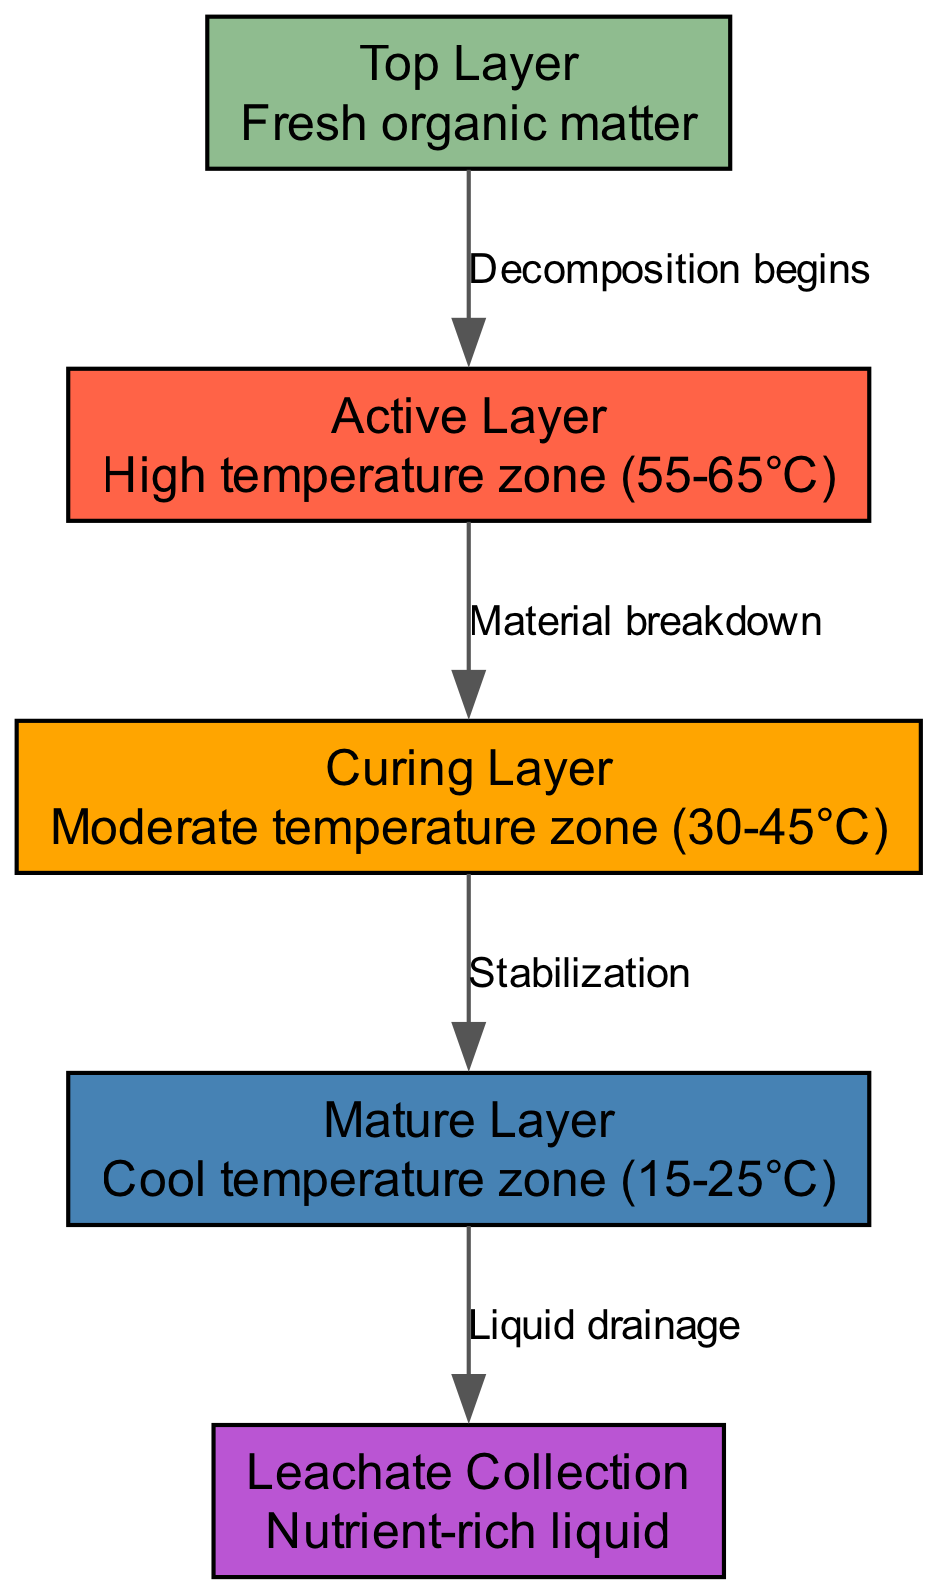What is the top layer of the compost bin? The diagram labels the top layer as "Fresh organic matter," indicating the type of material present in that section of the compost bin.
Answer: Fresh organic matter What temperature range is associated with the active layer? The diagram specifies that the active layer has a high temperature zone ranging from 55 to 65 degrees Celsius.
Answer: 55-65°C How many layers are there in total? By counting the nodes in the diagram, we find there are four distinct layers: Top Layer, Active Layer, Curing Layer, and Mature Layer.
Answer: 4 What process occurs between the active layer and the curing layer? The diagram indicates that the process between the active layer and curing layer is labeled as "Material breakdown," signifying the action that occurs between these two zones.
Answer: Material breakdown What is collected at the bottom of the compost bin? The diagram defines that the leachate collection area is for "Nutrient-rich liquid," which is what is collected in this part of the compost bin.
Answer: Nutrient-rich liquid What is the relationship labeled between the curing layer and the mature layer? The diagram illustrates that the curing layer transitions to the mature layer through a process labeled as "Stabilization," describing the process involved in the transition from one layer to the next.
Answer: Stabilization Which layer is characterized as having the coolest temperature zone? The diagram describes the mature layer as the cool temperature zone, which ranges from 15 to 25 degrees Celsius, identifying it as the coolest layer in the compost bin.
Answer: Mature Layer What layer does decomposition begin? According to the diagram, decomposition starts in the top layer, illustrating where the composting process initiates.
Answer: Top Layer Which layer is directly above the leachate collection? The diagram shows that the mature layer is directly above the leachate collection area, indicating the vertical relationship between these two components.
Answer: Mature Layer 